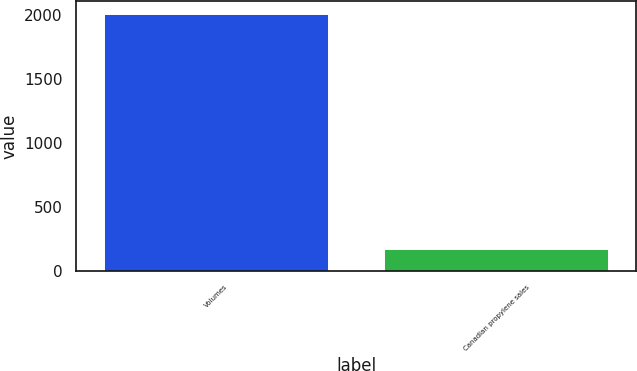<chart> <loc_0><loc_0><loc_500><loc_500><bar_chart><fcel>Volumes<fcel>Canadian propylene sales<nl><fcel>2013<fcel>172<nl></chart> 